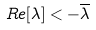<formula> <loc_0><loc_0><loc_500><loc_500>R e [ \lambda ] < - \overline { \lambda }</formula> 